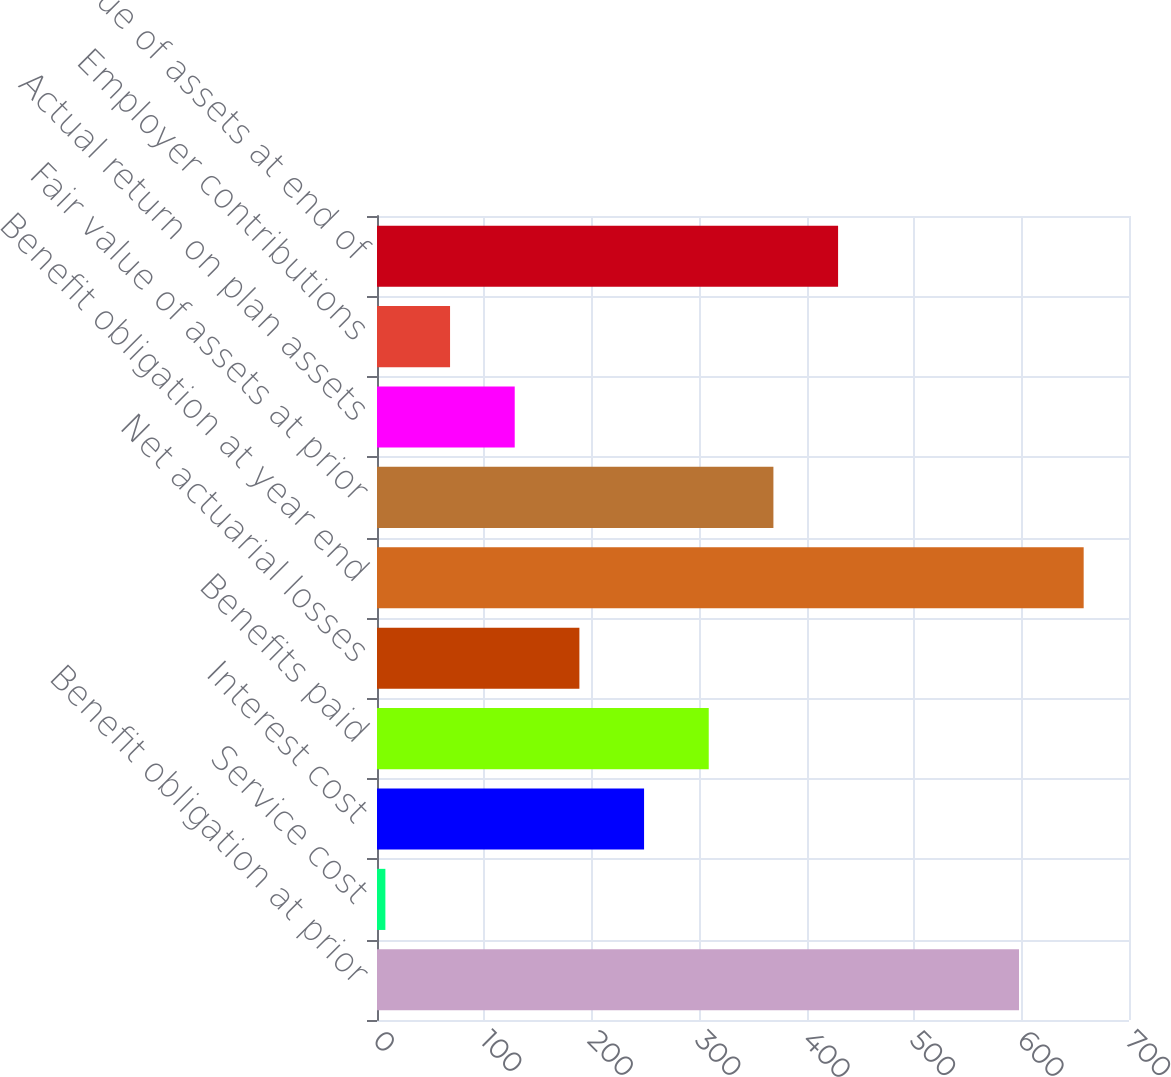Convert chart. <chart><loc_0><loc_0><loc_500><loc_500><bar_chart><fcel>Benefit obligation at prior<fcel>Service cost<fcel>Interest cost<fcel>Benefits paid<fcel>Net actuarial losses<fcel>Benefit obligation at year end<fcel>Fair value of assets at prior<fcel>Actual return on plan assets<fcel>Employer contributions<fcel>Fair value of assets at end of<nl><fcel>597.6<fcel>7.8<fcel>248.6<fcel>308.8<fcel>188.4<fcel>657.8<fcel>369<fcel>128.2<fcel>68<fcel>429.2<nl></chart> 